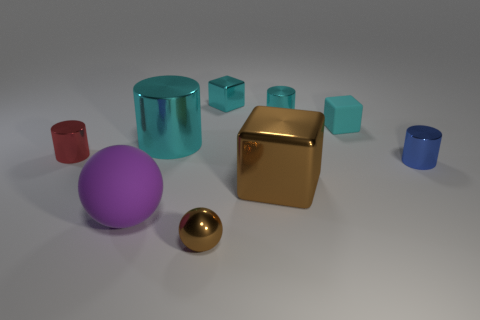Please explain the composition of this image. The composition of this image showcases a collection of geometric shapes arranged in a somewhat scattered yet visually pleasing manner. Objects are separated enough to be distinct but positioned to create a sense of balance and harmony. There is a variety of shapes, sizes, and colors that draw the viewer's eye across the scene, and the use of negative space ensures that each object is highlighted in its own right. 